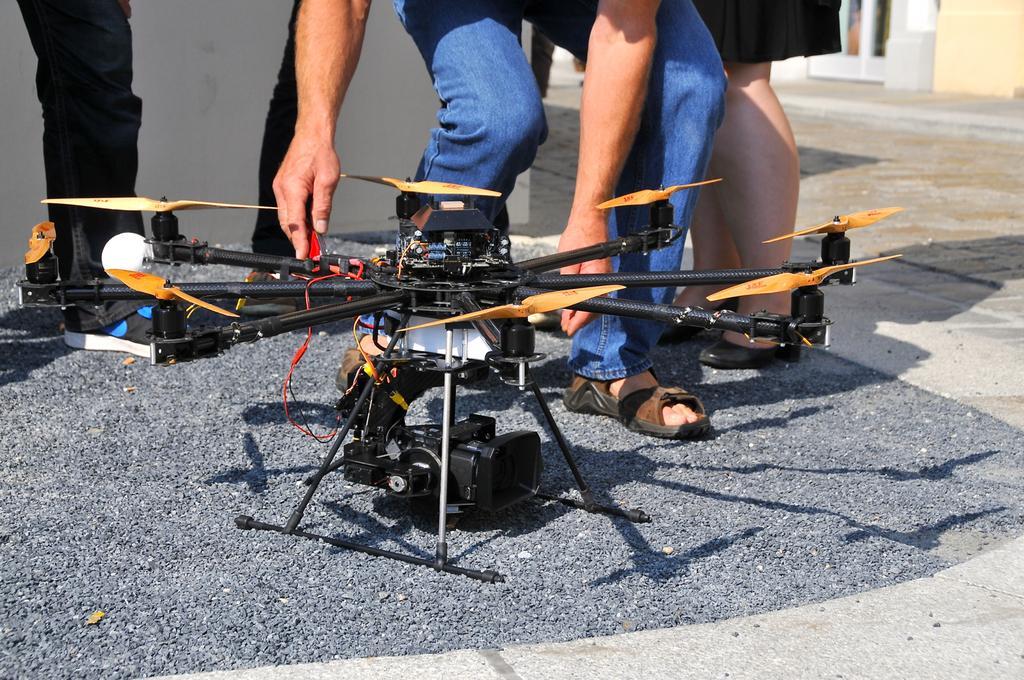In one or two sentences, can you explain what this image depicts? In this image, we can see persons legs. There is a drone in the middle of the image. 